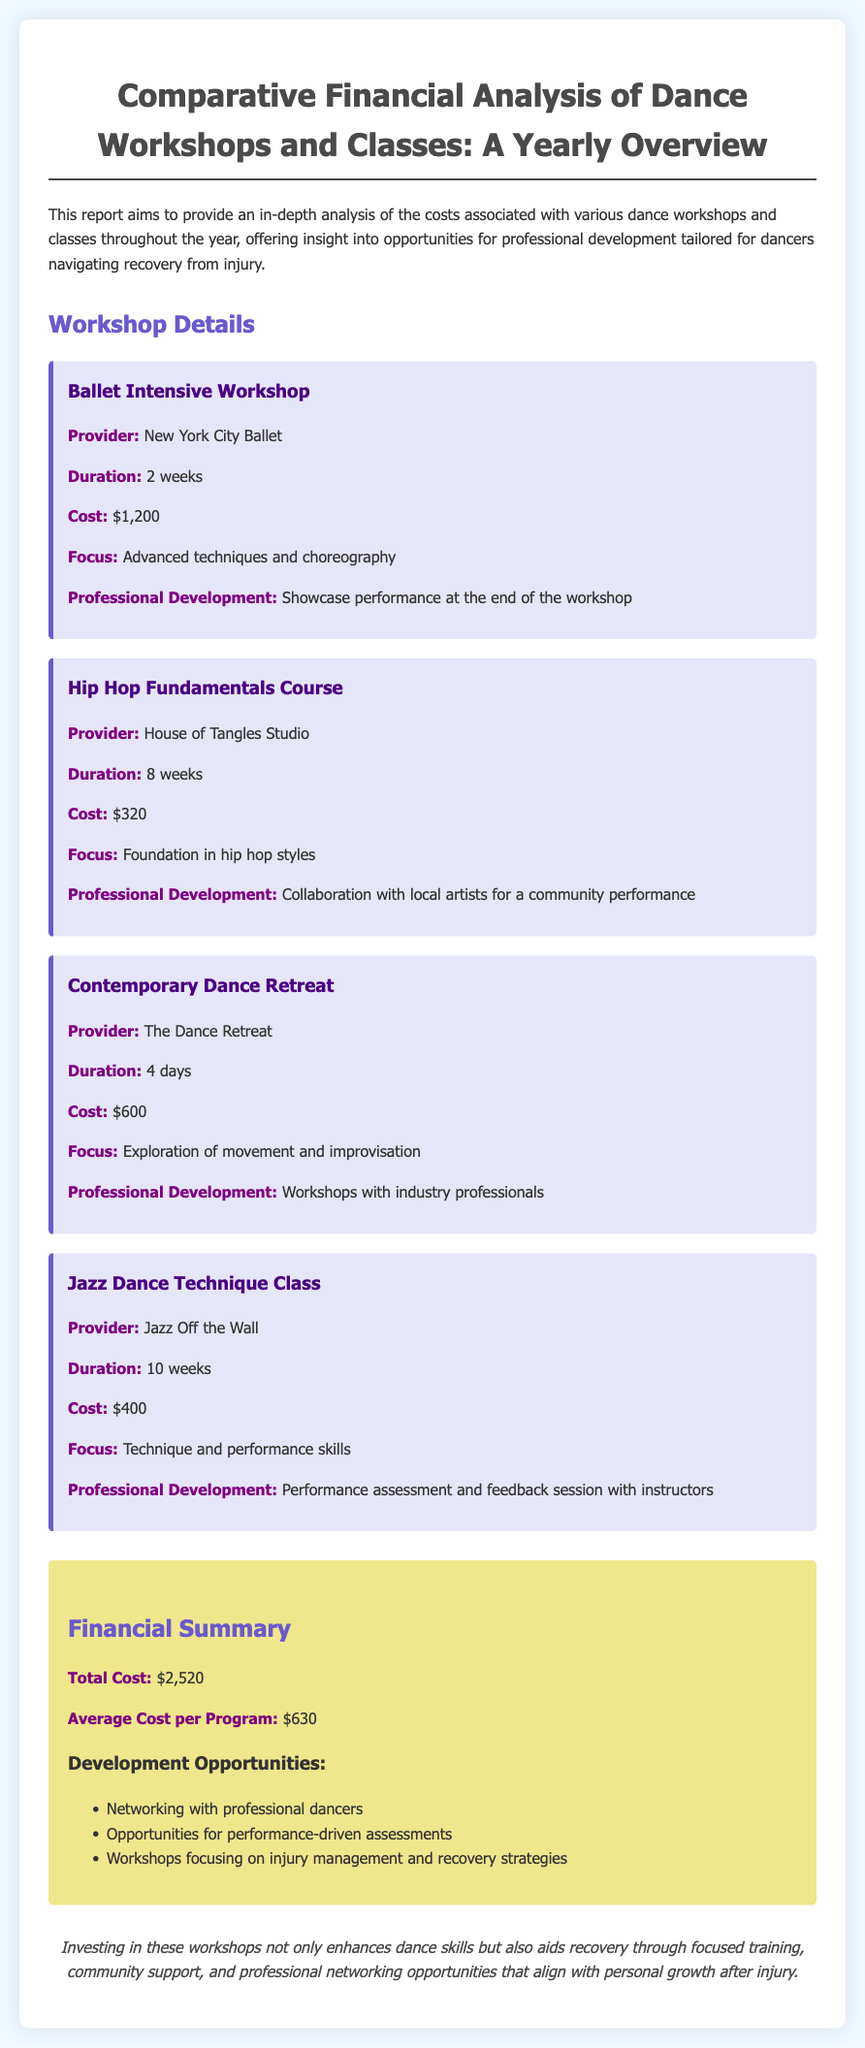What is the cost of the Ballet Intensive Workshop? The cost is specified in the workshop details for the Ballet Intensive Workshop, which is $1,200.
Answer: $1,200 Which provider offers the Hip Hop Fundamentals Course? The provider for the Hip Hop Fundamentals Course is mentioned in the workshop details, which is House of Tangles Studio.
Answer: House of Tangles Studio What is the duration of the Contemporary Dance Retreat? The duration is specified in the workshop details, which is 4 days.
Answer: 4 days What is the average cost per program? The average cost is calculated and mentioned in the financial summary, which is $630.
Answer: $630 What professional development opportunity is associated with the Jazz Dance Technique Class? The specific opportunity is listed in the workshop details, which is a performance assessment and feedback session with instructors.
Answer: Performance assessment and feedback session with instructors How many workshops are listed in the document? Count the number of distinct workshops mentioned, which totals 4.
Answer: 4 What is the total cost for all workshops? The total cost is provided in the financial summary as the sum of all workshop costs, which is $2,520.
Answer: $2,520 What focus area is highlighted for the Contemporary Dance Retreat? The focus area is specified in the workshop details, which is exploration of movement and improvisation.
Answer: Exploration of movement and improvisation What type of report is this document? The document type is described in the title, which is a comparative financial analysis.
Answer: Comparative financial analysis 